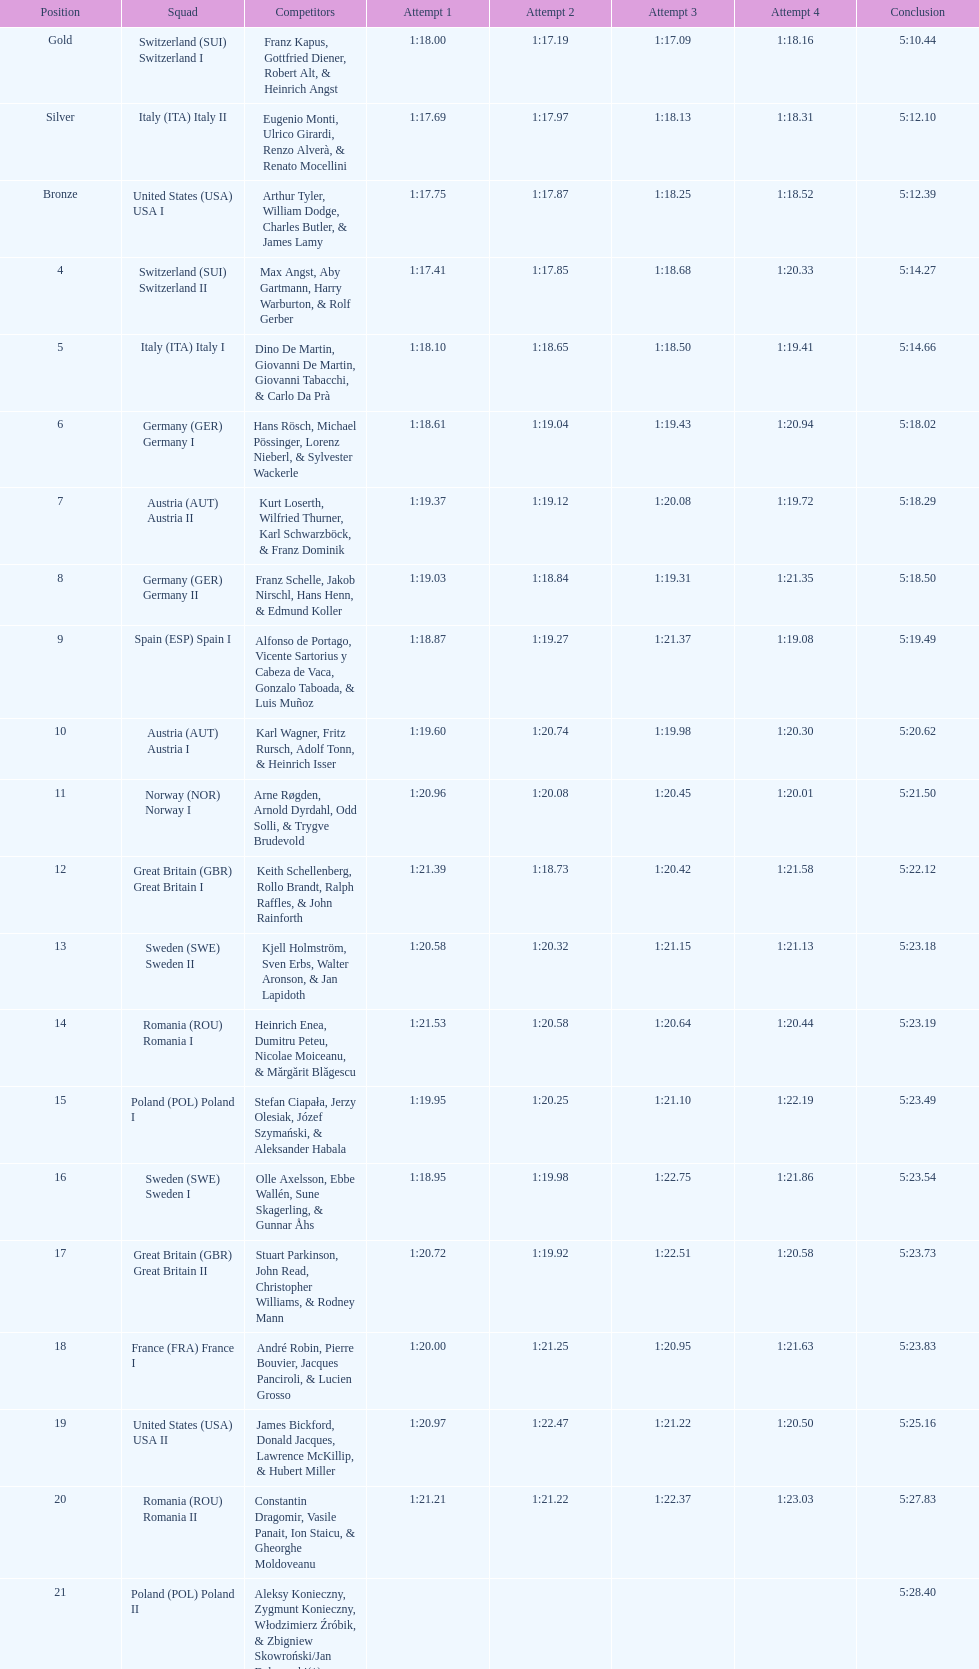What team comes after italy (ita) italy i? Germany I. 